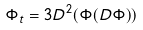Convert formula to latex. <formula><loc_0><loc_0><loc_500><loc_500>\Phi _ { t } = 3 D ^ { 2 } ( \Phi ( D \Phi ) )</formula> 